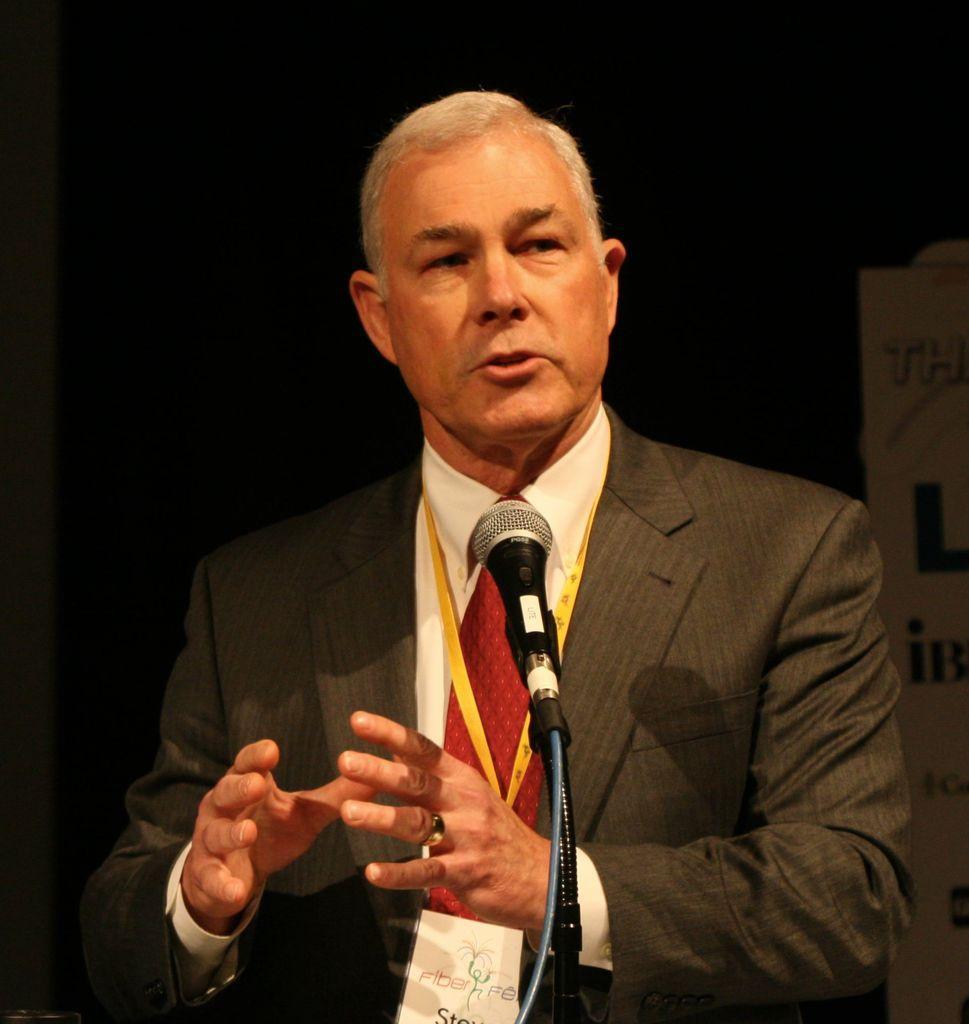How would you summarize this image in a sentence or two? In the center of the image there is a man holding mic. 